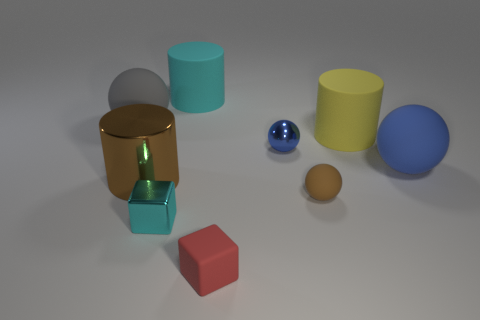Subtract all big shiny cylinders. How many cylinders are left? 2 Subtract all gray spheres. How many spheres are left? 3 Subtract all cylinders. How many objects are left? 6 Subtract 2 cubes. How many cubes are left? 0 Add 1 big brown cylinders. How many big brown cylinders are left? 2 Add 5 yellow cylinders. How many yellow cylinders exist? 6 Subtract 1 brown cylinders. How many objects are left? 8 Subtract all purple cylinders. Subtract all brown blocks. How many cylinders are left? 3 Subtract all red blocks. How many cyan balls are left? 0 Subtract all matte objects. Subtract all small blue things. How many objects are left? 2 